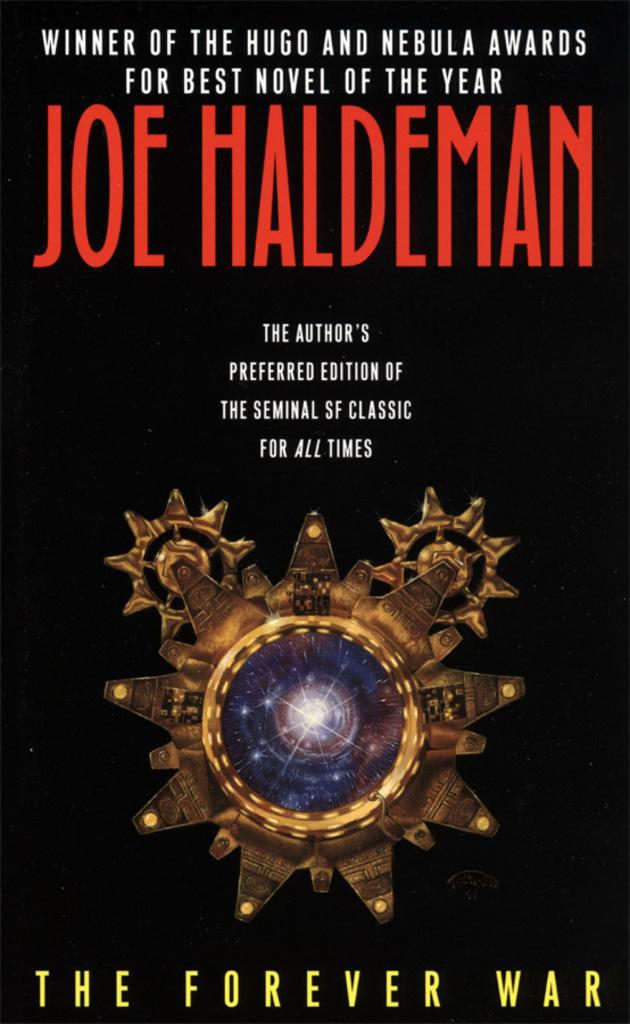<image>
Offer a succinct explanation of the picture presented. a book THE FOREVER WAR by JOE HALDEMAN. 